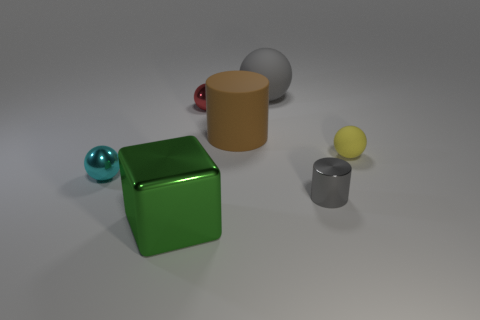There is a cylinder that is in front of the tiny yellow rubber thing; does it have the same color as the matte thing behind the large brown thing?
Give a very brief answer. Yes. What is the cylinder behind the metallic thing that is left of the big metallic thing made of?
Ensure brevity in your answer.  Rubber. There is a big brown object that is the same material as the yellow ball; what shape is it?
Keep it short and to the point. Cylinder. Do the rubber cylinder and the gray metal object have the same size?
Keep it short and to the point. No. There is a thing that is to the left of the big thing in front of the small gray metallic object; what is its size?
Provide a succinct answer. Small. What shape is the matte thing that is the same color as the small metallic cylinder?
Your answer should be compact. Sphere. What number of cylinders are gray rubber objects or big brown objects?
Offer a terse response. 1. There is a gray rubber ball; is its size the same as the cylinder behind the small cyan shiny object?
Make the answer very short. Yes. Are there more small yellow matte spheres behind the large green thing than large red rubber cylinders?
Provide a short and direct response. Yes. What size is the cyan ball that is made of the same material as the small red ball?
Offer a terse response. Small. 